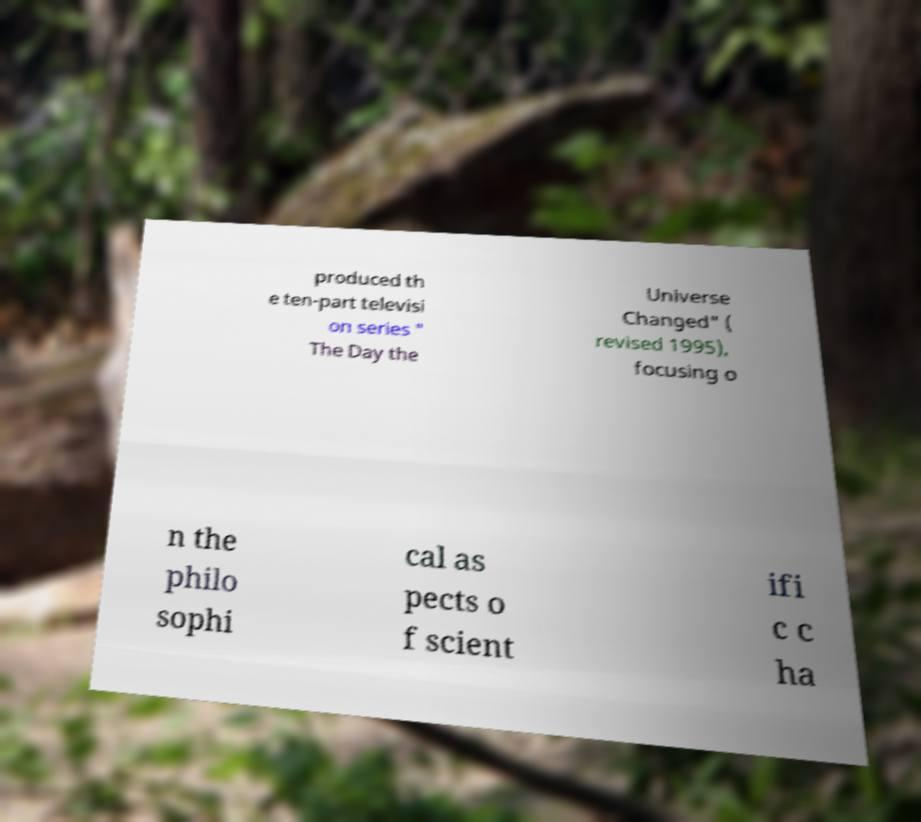Please identify and transcribe the text found in this image. produced th e ten-part televisi on series " The Day the Universe Changed" ( revised 1995), focusing o n the philo sophi cal as pects o f scient ifi c c ha 